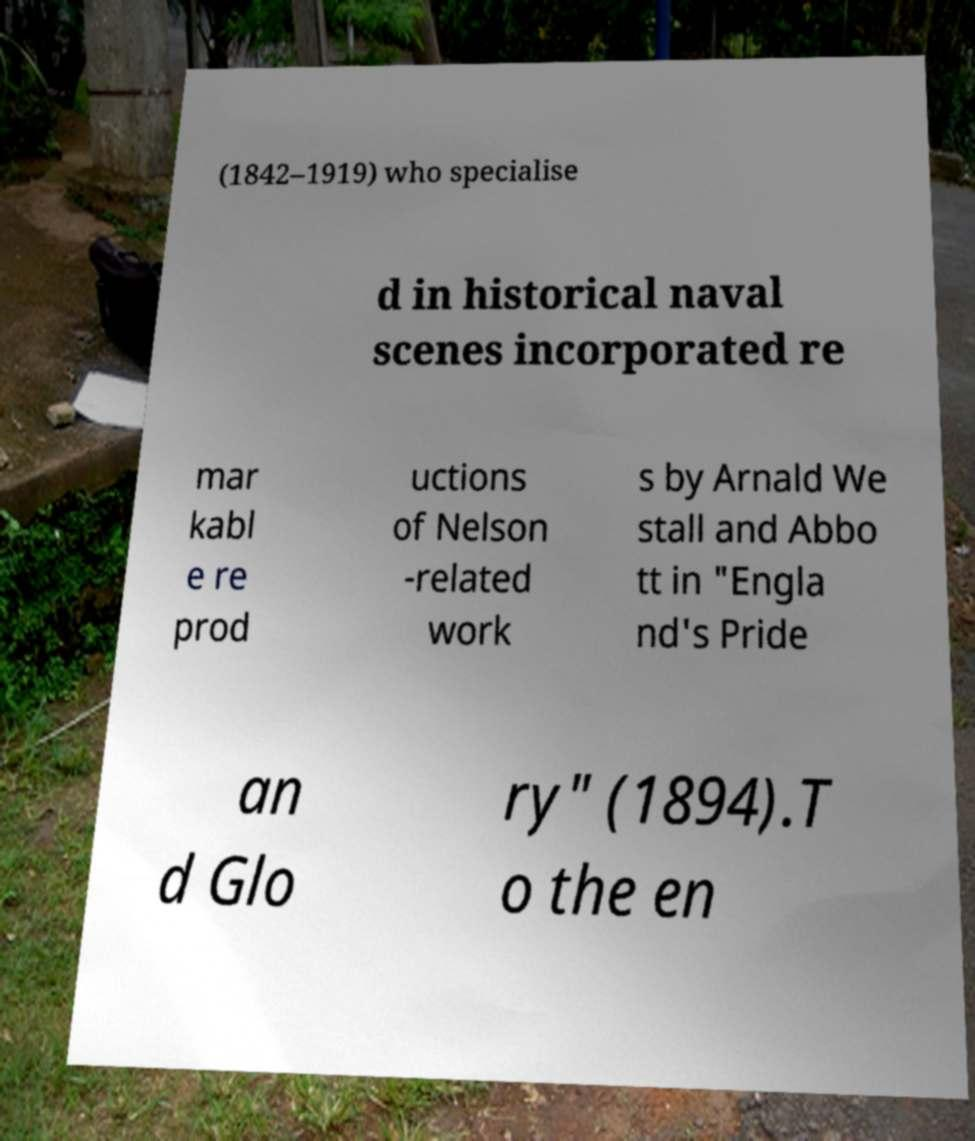There's text embedded in this image that I need extracted. Can you transcribe it verbatim? (1842–1919) who specialise d in historical naval scenes incorporated re mar kabl e re prod uctions of Nelson -related work s by Arnald We stall and Abbo tt in "Engla nd's Pride an d Glo ry" (1894).T o the en 